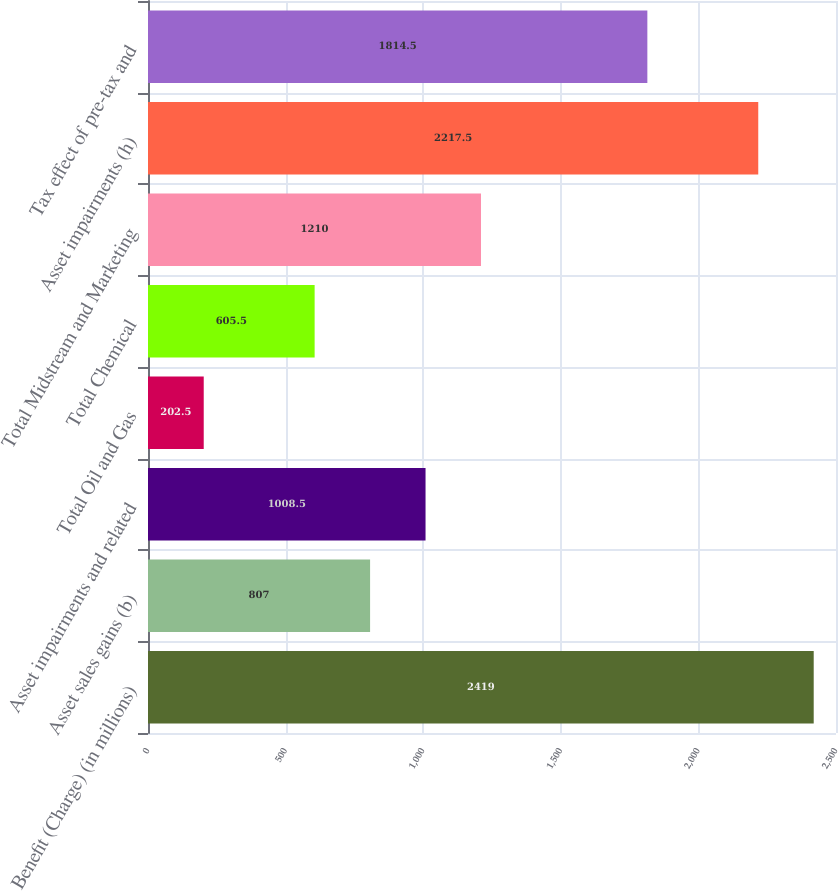<chart> <loc_0><loc_0><loc_500><loc_500><bar_chart><fcel>Benefit (Charge) (in millions)<fcel>Asset sales gains (b)<fcel>Asset impairments and related<fcel>Total Oil and Gas<fcel>Total Chemical<fcel>Total Midstream and Marketing<fcel>Asset impairments (h)<fcel>Tax effect of pre-tax and<nl><fcel>2419<fcel>807<fcel>1008.5<fcel>202.5<fcel>605.5<fcel>1210<fcel>2217.5<fcel>1814.5<nl></chart> 